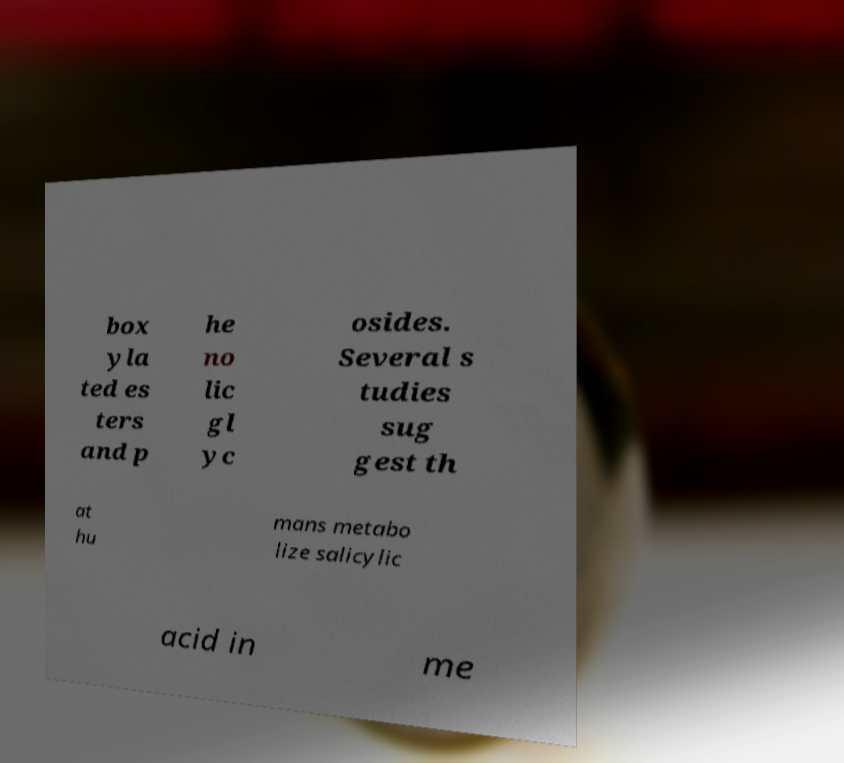Please identify and transcribe the text found in this image. box yla ted es ters and p he no lic gl yc osides. Several s tudies sug gest th at hu mans metabo lize salicylic acid in me 